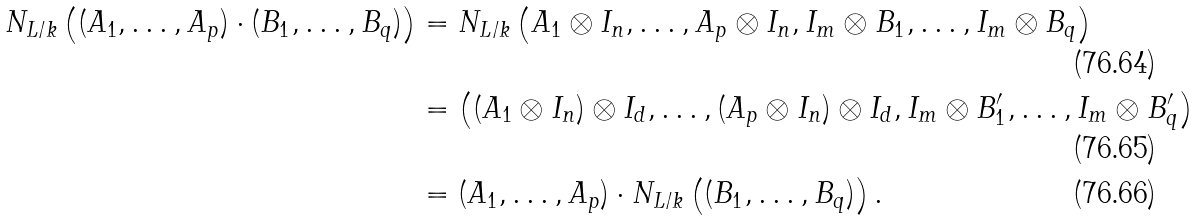<formula> <loc_0><loc_0><loc_500><loc_500>N _ { L / k } \left ( ( A _ { 1 } , \dots , A _ { p } ) \cdot ( B _ { 1 } , \dots , B _ { q } ) \right ) & = N _ { L / k } \left ( A _ { 1 } \otimes I _ { n } , \dots , A _ { p } \otimes I _ { n } , I _ { m } \otimes B _ { 1 } , \dots , I _ { m } \otimes B _ { q } \right ) \\ & = \left ( ( A _ { 1 } \otimes I _ { n } ) \otimes I _ { d } , \dots , ( A _ { p } \otimes I _ { n } ) \otimes I _ { d } , I _ { m } \otimes B ^ { \prime } _ { 1 } , \dots , I _ { m } \otimes B ^ { \prime } _ { q } \right ) \\ & = ( A _ { 1 } , \dots , A _ { p } ) \cdot N _ { L / k } \left ( ( B _ { 1 } , \dots , B _ { q } ) \right ) .</formula> 